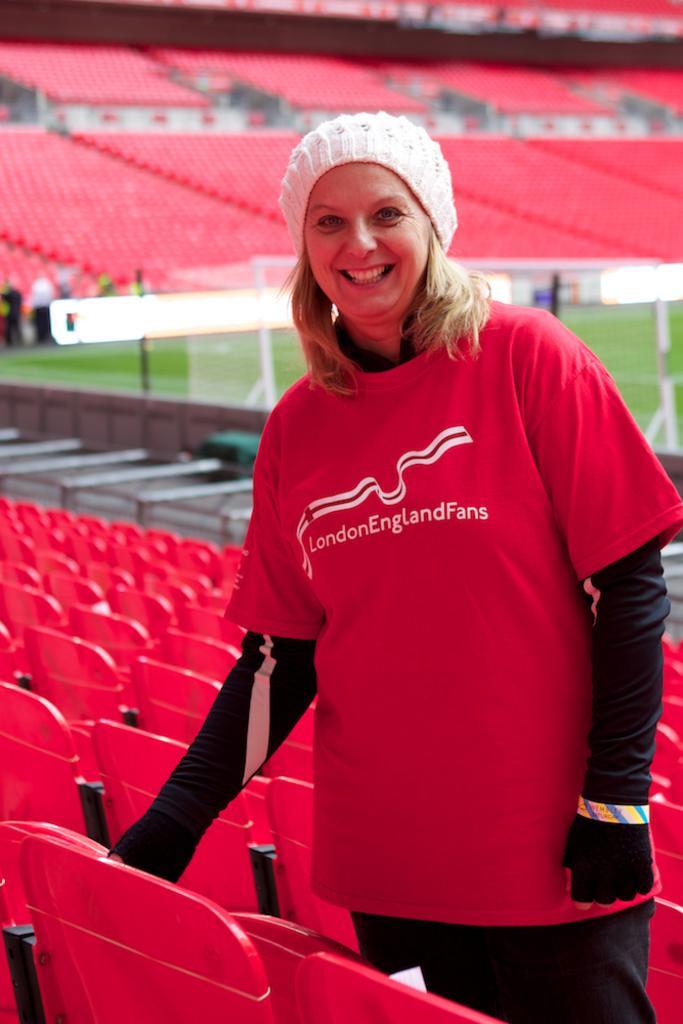Please provide a concise description of this image. In the foreground of the picture there is a woman standing and there are chairs. The picture is clicked in a stadium. In the background there are chairs. In the center of the picture there is a football goal post and football ground. 